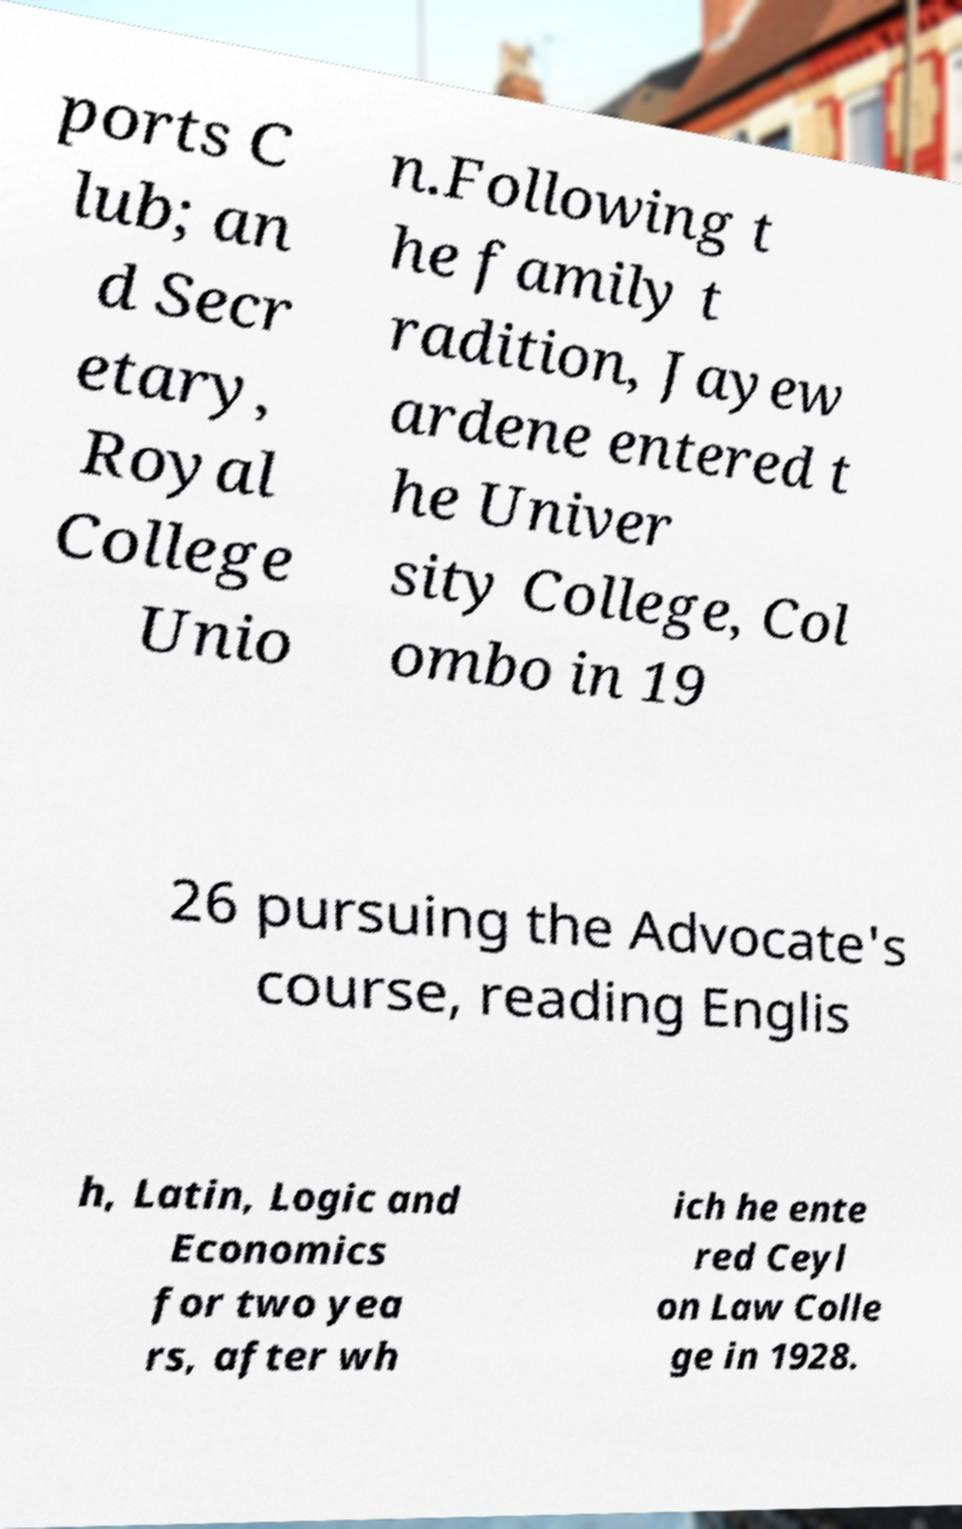What messages or text are displayed in this image? I need them in a readable, typed format. ports C lub; an d Secr etary, Royal College Unio n.Following t he family t radition, Jayew ardene entered t he Univer sity College, Col ombo in 19 26 pursuing the Advocate's course, reading Englis h, Latin, Logic and Economics for two yea rs, after wh ich he ente red Ceyl on Law Colle ge in 1928. 